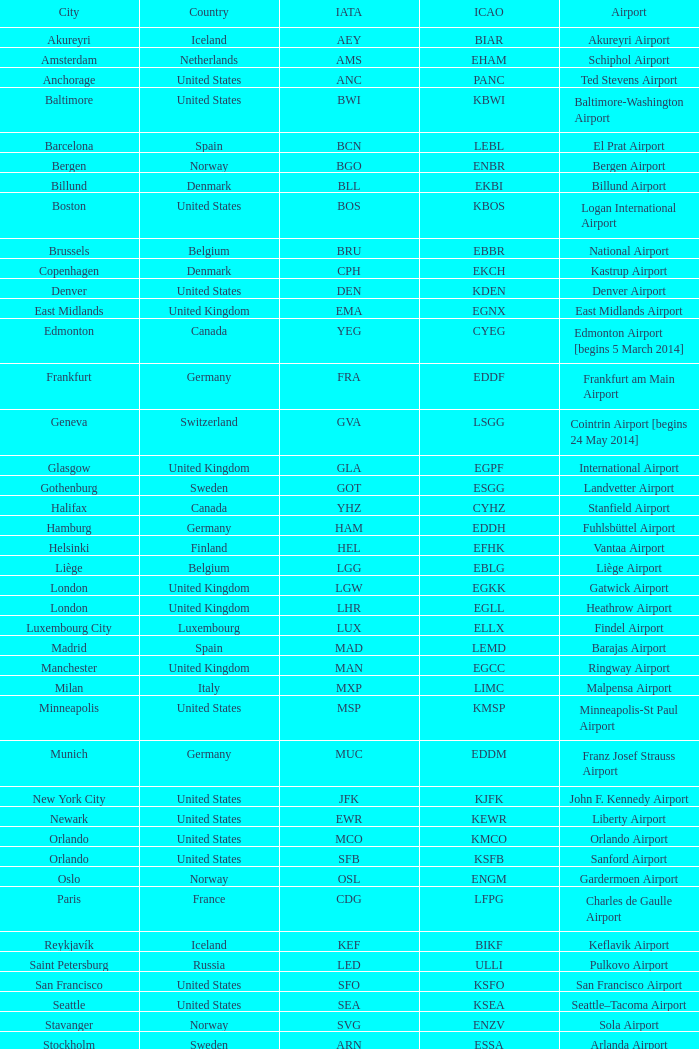What is the IcAO of Frankfurt? EDDF. 